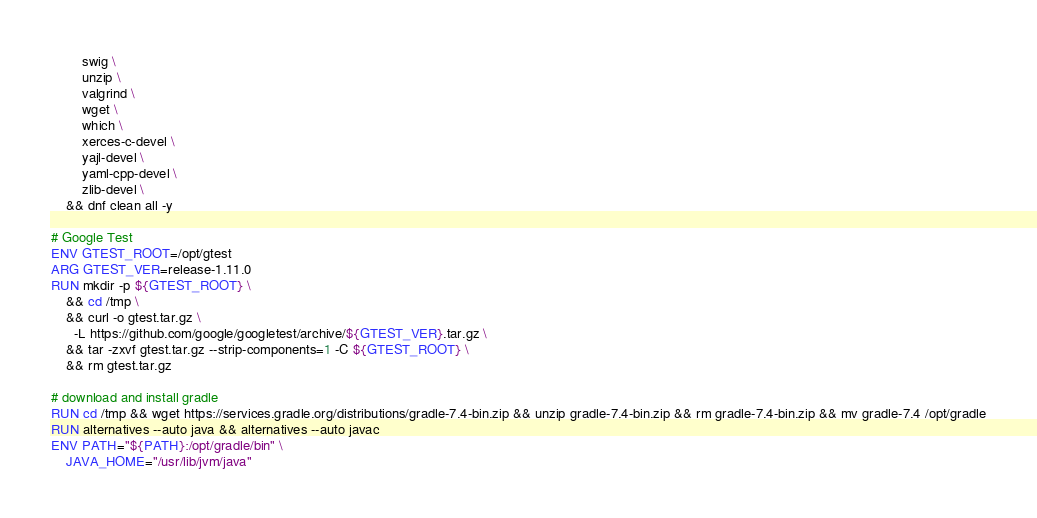Convert code to text. <code><loc_0><loc_0><loc_500><loc_500><_Dockerfile_>        swig \
        unzip \
        valgrind \
        wget \
        which \
        xerces-c-devel \
        yajl-devel \
        yaml-cpp-devel \
        zlib-devel \
    && dnf clean all -y

# Google Test
ENV GTEST_ROOT=/opt/gtest
ARG GTEST_VER=release-1.11.0
RUN mkdir -p ${GTEST_ROOT} \
    && cd /tmp \
    && curl -o gtest.tar.gz \
      -L https://github.com/google/googletest/archive/${GTEST_VER}.tar.gz \
    && tar -zxvf gtest.tar.gz --strip-components=1 -C ${GTEST_ROOT} \
    && rm gtest.tar.gz

# download and install gradle
RUN cd /tmp && wget https://services.gradle.org/distributions/gradle-7.4-bin.zip && unzip gradle-7.4-bin.zip && rm gradle-7.4-bin.zip && mv gradle-7.4 /opt/gradle
RUN alternatives --auto java && alternatives --auto javac
ENV PATH="${PATH}:/opt/gradle/bin" \
    JAVA_HOME="/usr/lib/jvm/java"
</code> 